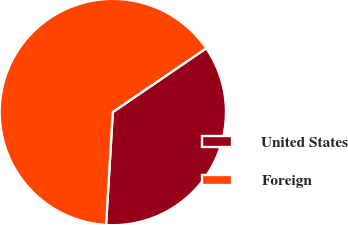<chart> <loc_0><loc_0><loc_500><loc_500><pie_chart><fcel>United States<fcel>Foreign<nl><fcel>35.49%<fcel>64.51%<nl></chart> 